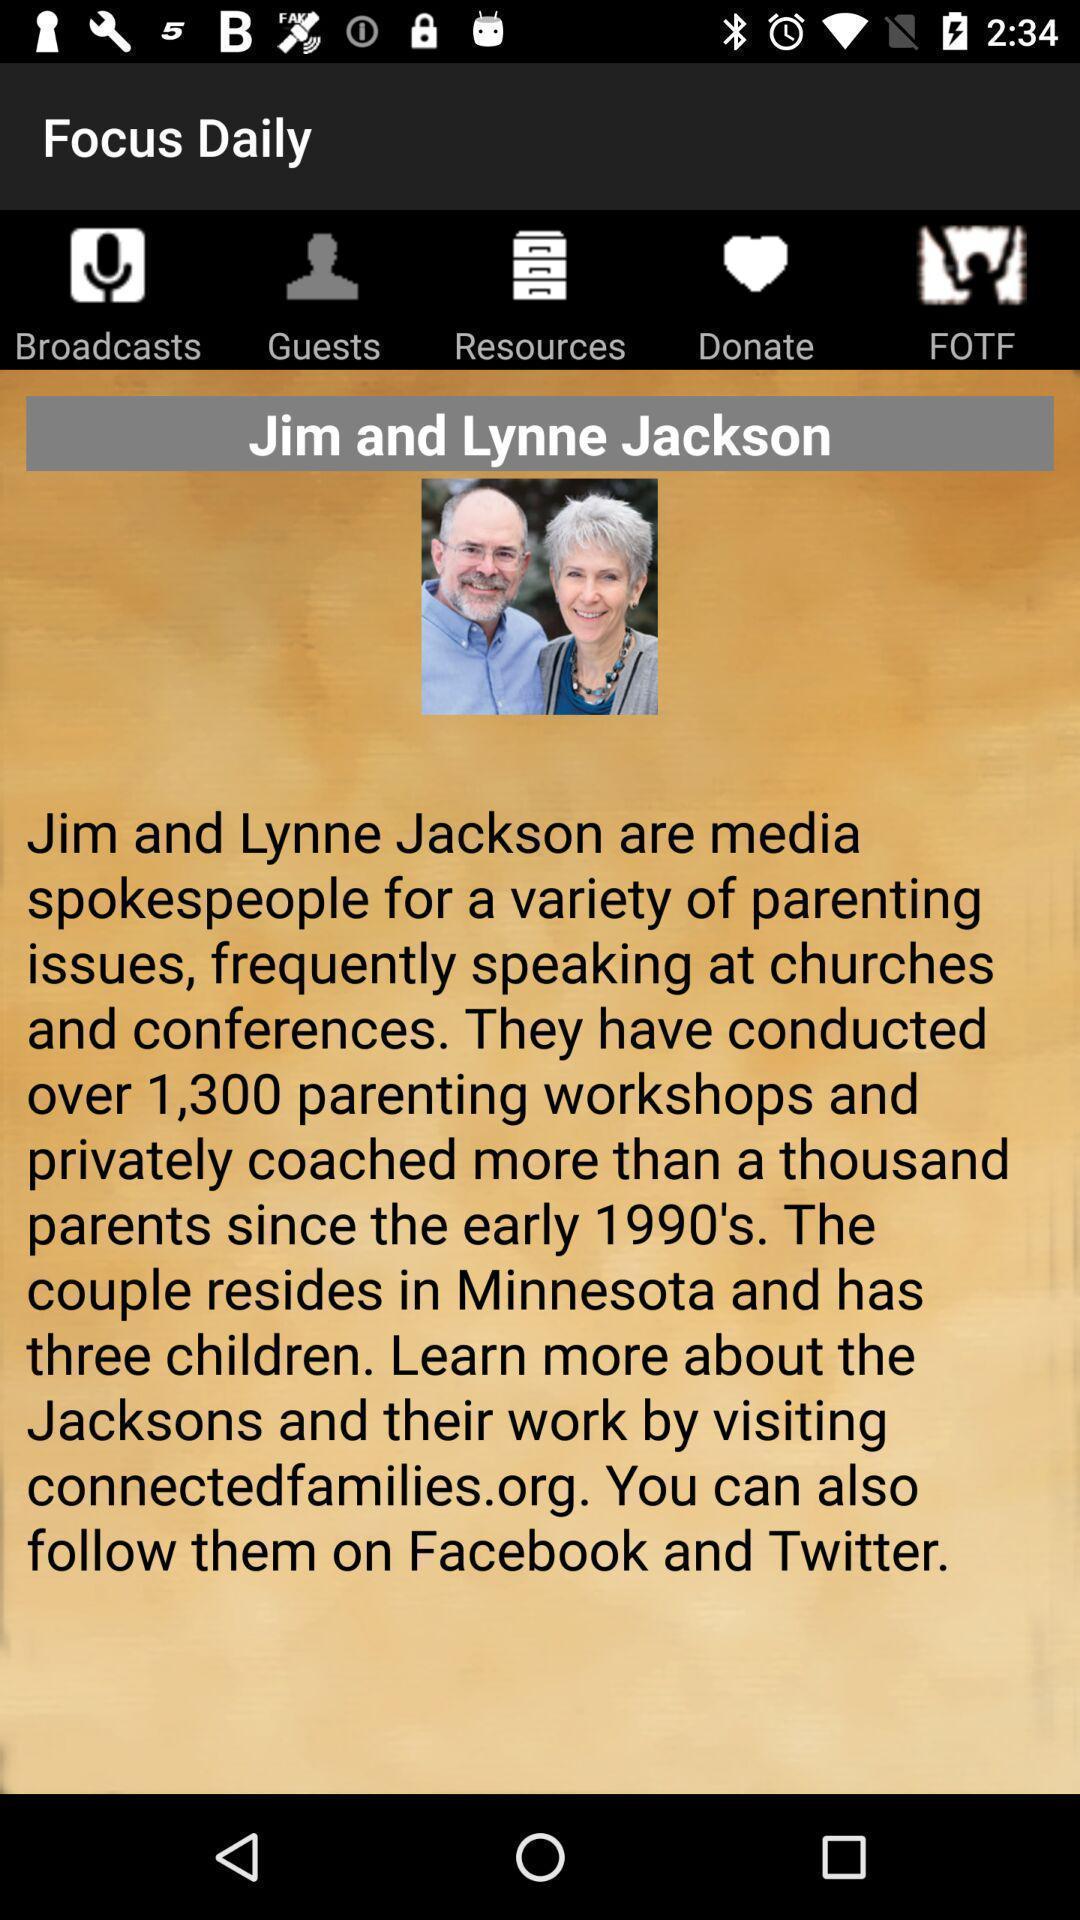Provide a detailed account of this screenshot. Spokespeople page of a christian radio app. 